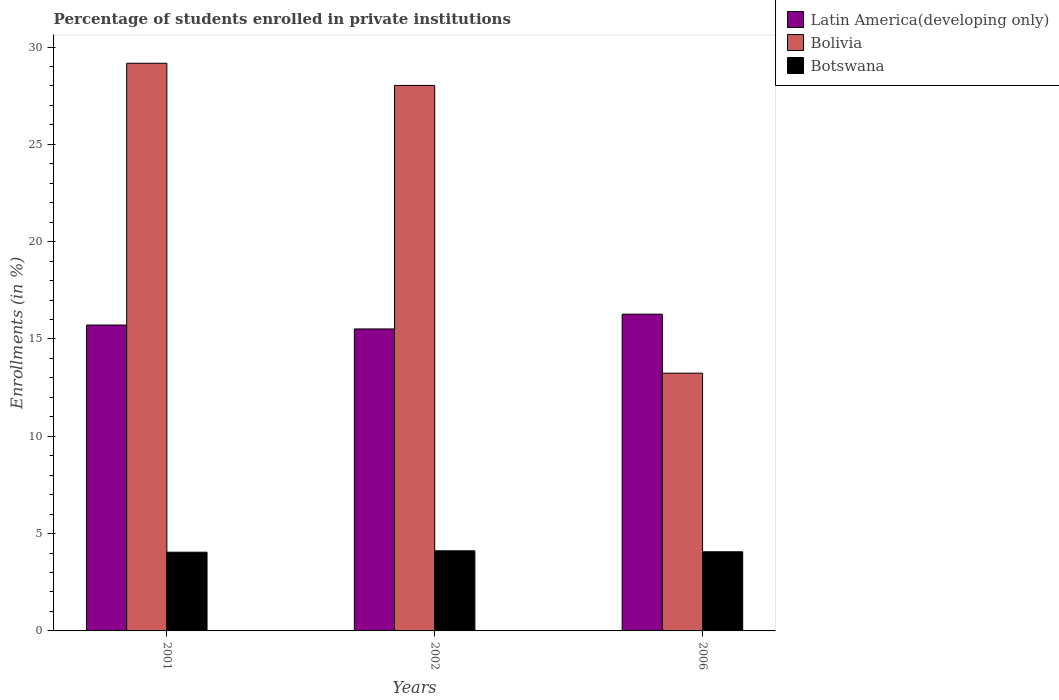How many different coloured bars are there?
Your response must be concise. 3. How many groups of bars are there?
Offer a very short reply. 3. What is the label of the 2nd group of bars from the left?
Give a very brief answer. 2002. In how many cases, is the number of bars for a given year not equal to the number of legend labels?
Keep it short and to the point. 0. What is the percentage of trained teachers in Bolivia in 2001?
Offer a terse response. 29.17. Across all years, what is the maximum percentage of trained teachers in Bolivia?
Your answer should be very brief. 29.17. Across all years, what is the minimum percentage of trained teachers in Bolivia?
Keep it short and to the point. 13.24. In which year was the percentage of trained teachers in Bolivia minimum?
Your response must be concise. 2006. What is the total percentage of trained teachers in Bolivia in the graph?
Keep it short and to the point. 70.43. What is the difference between the percentage of trained teachers in Latin America(developing only) in 2001 and that in 2002?
Your response must be concise. 0.2. What is the difference between the percentage of trained teachers in Bolivia in 2001 and the percentage of trained teachers in Latin America(developing only) in 2006?
Provide a short and direct response. 12.89. What is the average percentage of trained teachers in Latin America(developing only) per year?
Offer a very short reply. 15.83. In the year 2002, what is the difference between the percentage of trained teachers in Botswana and percentage of trained teachers in Latin America(developing only)?
Your answer should be very brief. -11.4. What is the ratio of the percentage of trained teachers in Bolivia in 2002 to that in 2006?
Offer a terse response. 2.12. What is the difference between the highest and the second highest percentage of trained teachers in Latin America(developing only)?
Keep it short and to the point. 0.56. What is the difference between the highest and the lowest percentage of trained teachers in Bolivia?
Provide a short and direct response. 15.92. In how many years, is the percentage of trained teachers in Botswana greater than the average percentage of trained teachers in Botswana taken over all years?
Your answer should be compact. 1. Is the sum of the percentage of trained teachers in Bolivia in 2001 and 2006 greater than the maximum percentage of trained teachers in Latin America(developing only) across all years?
Keep it short and to the point. Yes. What does the 1st bar from the left in 2002 represents?
Make the answer very short. Latin America(developing only). What does the 3rd bar from the right in 2001 represents?
Your answer should be compact. Latin America(developing only). Is it the case that in every year, the sum of the percentage of trained teachers in Bolivia and percentage of trained teachers in Botswana is greater than the percentage of trained teachers in Latin America(developing only)?
Provide a succinct answer. Yes. How many bars are there?
Keep it short and to the point. 9. Does the graph contain grids?
Your answer should be compact. No. Where does the legend appear in the graph?
Ensure brevity in your answer.  Top right. How many legend labels are there?
Offer a very short reply. 3. How are the legend labels stacked?
Your answer should be compact. Vertical. What is the title of the graph?
Make the answer very short. Percentage of students enrolled in private institutions. What is the label or title of the X-axis?
Provide a succinct answer. Years. What is the label or title of the Y-axis?
Make the answer very short. Enrollments (in %). What is the Enrollments (in %) in Latin America(developing only) in 2001?
Give a very brief answer. 15.72. What is the Enrollments (in %) in Bolivia in 2001?
Offer a very short reply. 29.17. What is the Enrollments (in %) in Botswana in 2001?
Give a very brief answer. 4.04. What is the Enrollments (in %) in Latin America(developing only) in 2002?
Offer a terse response. 15.51. What is the Enrollments (in %) in Bolivia in 2002?
Your response must be concise. 28.03. What is the Enrollments (in %) in Botswana in 2002?
Your response must be concise. 4.12. What is the Enrollments (in %) of Latin America(developing only) in 2006?
Provide a succinct answer. 16.27. What is the Enrollments (in %) of Bolivia in 2006?
Offer a terse response. 13.24. What is the Enrollments (in %) of Botswana in 2006?
Your answer should be compact. 4.07. Across all years, what is the maximum Enrollments (in %) in Latin America(developing only)?
Your response must be concise. 16.27. Across all years, what is the maximum Enrollments (in %) of Bolivia?
Give a very brief answer. 29.17. Across all years, what is the maximum Enrollments (in %) of Botswana?
Offer a very short reply. 4.12. Across all years, what is the minimum Enrollments (in %) of Latin America(developing only)?
Your answer should be compact. 15.51. Across all years, what is the minimum Enrollments (in %) in Bolivia?
Ensure brevity in your answer.  13.24. Across all years, what is the minimum Enrollments (in %) of Botswana?
Your answer should be compact. 4.04. What is the total Enrollments (in %) in Latin America(developing only) in the graph?
Offer a terse response. 47.5. What is the total Enrollments (in %) in Bolivia in the graph?
Give a very brief answer. 70.43. What is the total Enrollments (in %) of Botswana in the graph?
Provide a short and direct response. 12.23. What is the difference between the Enrollments (in %) in Latin America(developing only) in 2001 and that in 2002?
Your answer should be very brief. 0.2. What is the difference between the Enrollments (in %) of Bolivia in 2001 and that in 2002?
Provide a succinct answer. 1.14. What is the difference between the Enrollments (in %) in Botswana in 2001 and that in 2002?
Ensure brevity in your answer.  -0.07. What is the difference between the Enrollments (in %) in Latin America(developing only) in 2001 and that in 2006?
Offer a terse response. -0.56. What is the difference between the Enrollments (in %) in Bolivia in 2001 and that in 2006?
Provide a succinct answer. 15.92. What is the difference between the Enrollments (in %) of Botswana in 2001 and that in 2006?
Offer a very short reply. -0.02. What is the difference between the Enrollments (in %) in Latin America(developing only) in 2002 and that in 2006?
Your response must be concise. -0.76. What is the difference between the Enrollments (in %) in Bolivia in 2002 and that in 2006?
Keep it short and to the point. 14.78. What is the difference between the Enrollments (in %) of Botswana in 2002 and that in 2006?
Provide a short and direct response. 0.05. What is the difference between the Enrollments (in %) in Latin America(developing only) in 2001 and the Enrollments (in %) in Bolivia in 2002?
Provide a succinct answer. -12.31. What is the difference between the Enrollments (in %) of Latin America(developing only) in 2001 and the Enrollments (in %) of Botswana in 2002?
Keep it short and to the point. 11.6. What is the difference between the Enrollments (in %) of Bolivia in 2001 and the Enrollments (in %) of Botswana in 2002?
Offer a terse response. 25.05. What is the difference between the Enrollments (in %) in Latin America(developing only) in 2001 and the Enrollments (in %) in Bolivia in 2006?
Keep it short and to the point. 2.47. What is the difference between the Enrollments (in %) in Latin America(developing only) in 2001 and the Enrollments (in %) in Botswana in 2006?
Ensure brevity in your answer.  11.65. What is the difference between the Enrollments (in %) of Bolivia in 2001 and the Enrollments (in %) of Botswana in 2006?
Provide a short and direct response. 25.1. What is the difference between the Enrollments (in %) in Latin America(developing only) in 2002 and the Enrollments (in %) in Bolivia in 2006?
Provide a succinct answer. 2.27. What is the difference between the Enrollments (in %) of Latin America(developing only) in 2002 and the Enrollments (in %) of Botswana in 2006?
Keep it short and to the point. 11.45. What is the difference between the Enrollments (in %) of Bolivia in 2002 and the Enrollments (in %) of Botswana in 2006?
Offer a terse response. 23.96. What is the average Enrollments (in %) in Latin America(developing only) per year?
Your response must be concise. 15.83. What is the average Enrollments (in %) of Bolivia per year?
Your answer should be very brief. 23.48. What is the average Enrollments (in %) of Botswana per year?
Provide a succinct answer. 4.08. In the year 2001, what is the difference between the Enrollments (in %) of Latin America(developing only) and Enrollments (in %) of Bolivia?
Offer a very short reply. -13.45. In the year 2001, what is the difference between the Enrollments (in %) in Latin America(developing only) and Enrollments (in %) in Botswana?
Give a very brief answer. 11.67. In the year 2001, what is the difference between the Enrollments (in %) in Bolivia and Enrollments (in %) in Botswana?
Your response must be concise. 25.12. In the year 2002, what is the difference between the Enrollments (in %) in Latin America(developing only) and Enrollments (in %) in Bolivia?
Your response must be concise. -12.51. In the year 2002, what is the difference between the Enrollments (in %) in Latin America(developing only) and Enrollments (in %) in Botswana?
Make the answer very short. 11.4. In the year 2002, what is the difference between the Enrollments (in %) of Bolivia and Enrollments (in %) of Botswana?
Keep it short and to the point. 23.91. In the year 2006, what is the difference between the Enrollments (in %) of Latin America(developing only) and Enrollments (in %) of Bolivia?
Offer a terse response. 3.03. In the year 2006, what is the difference between the Enrollments (in %) of Latin America(developing only) and Enrollments (in %) of Botswana?
Give a very brief answer. 12.21. In the year 2006, what is the difference between the Enrollments (in %) in Bolivia and Enrollments (in %) in Botswana?
Ensure brevity in your answer.  9.18. What is the ratio of the Enrollments (in %) of Bolivia in 2001 to that in 2002?
Your answer should be very brief. 1.04. What is the ratio of the Enrollments (in %) of Botswana in 2001 to that in 2002?
Ensure brevity in your answer.  0.98. What is the ratio of the Enrollments (in %) in Latin America(developing only) in 2001 to that in 2006?
Provide a short and direct response. 0.97. What is the ratio of the Enrollments (in %) of Bolivia in 2001 to that in 2006?
Your response must be concise. 2.2. What is the ratio of the Enrollments (in %) of Botswana in 2001 to that in 2006?
Offer a very short reply. 0.99. What is the ratio of the Enrollments (in %) in Latin America(developing only) in 2002 to that in 2006?
Provide a succinct answer. 0.95. What is the ratio of the Enrollments (in %) of Bolivia in 2002 to that in 2006?
Offer a very short reply. 2.12. What is the ratio of the Enrollments (in %) in Botswana in 2002 to that in 2006?
Ensure brevity in your answer.  1.01. What is the difference between the highest and the second highest Enrollments (in %) in Latin America(developing only)?
Make the answer very short. 0.56. What is the difference between the highest and the second highest Enrollments (in %) of Bolivia?
Offer a terse response. 1.14. What is the difference between the highest and the second highest Enrollments (in %) of Botswana?
Keep it short and to the point. 0.05. What is the difference between the highest and the lowest Enrollments (in %) in Latin America(developing only)?
Your response must be concise. 0.76. What is the difference between the highest and the lowest Enrollments (in %) of Bolivia?
Offer a very short reply. 15.92. What is the difference between the highest and the lowest Enrollments (in %) in Botswana?
Your response must be concise. 0.07. 